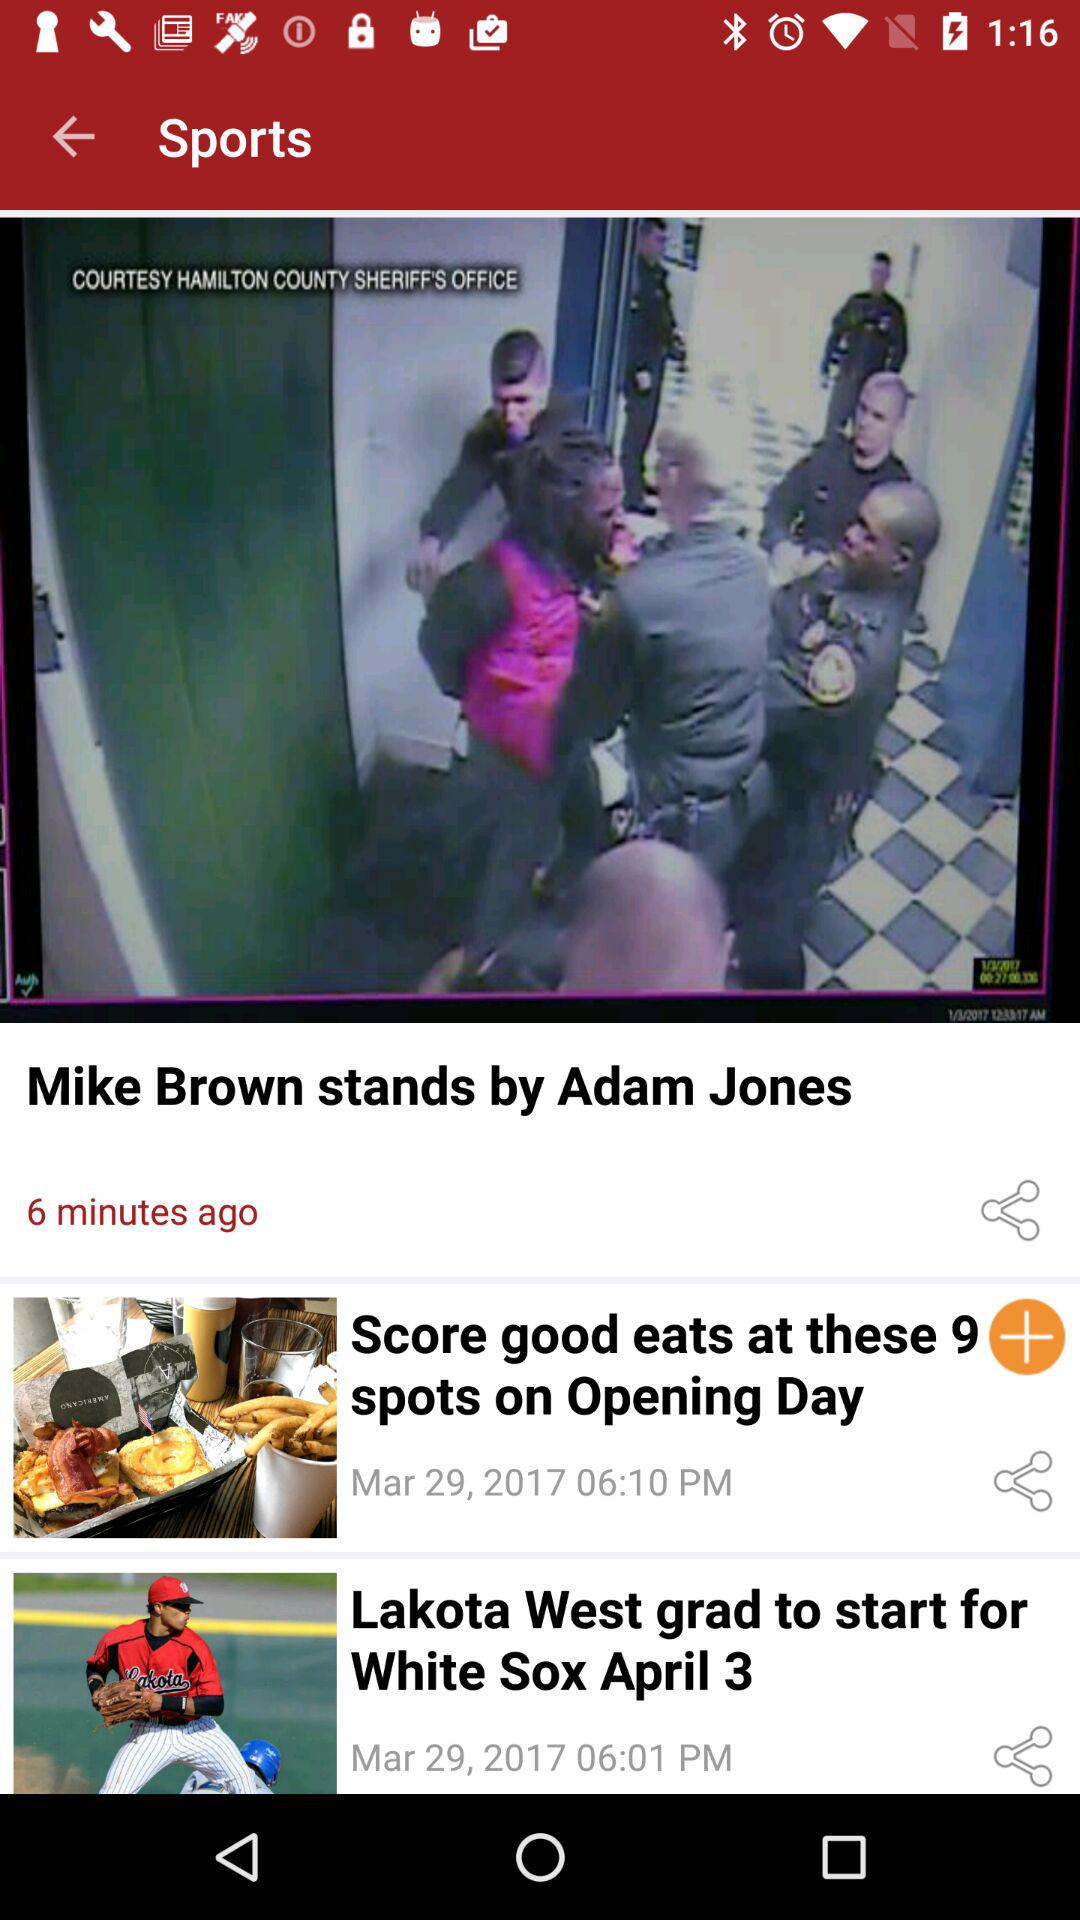When was the article "Lakota West grad to start for White Sox April 3" posted? It was posted on March 29, 2017 at 06:01 PM. 